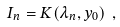Convert formula to latex. <formula><loc_0><loc_0><loc_500><loc_500>I _ { n } = K ( \lambda _ { n } , y _ { 0 } ) \ ,</formula> 